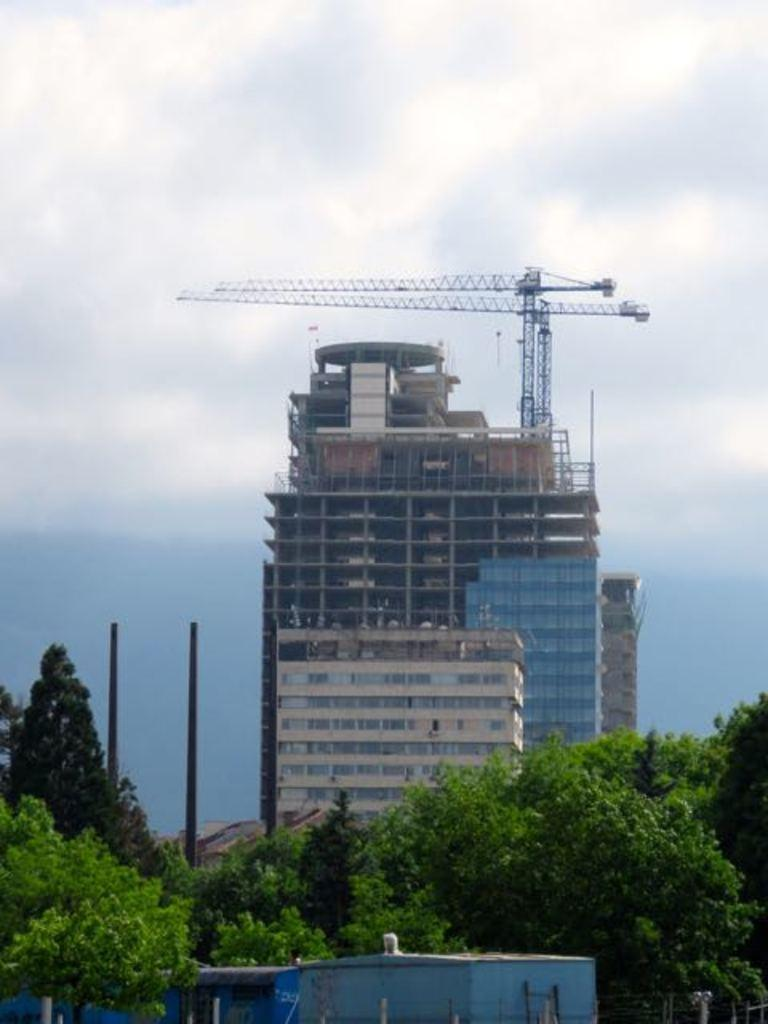What type of vegetation can be seen at the bottom of the image? There are trees at the bottom of the image. What type of structures are also present at the bottom of the image? There are sheds at the bottom of the image. What can be seen in the background of the image? There are buildings and the sky visible in the background of the image. What is the condition of the sky in the image? Clouds are present in the background of the image. What type of pain is being experienced by the person in the image? There is no person present in the image, so it is not possible to determine if anyone is experiencing pain. What record is being played in the image? There is no record player or music playing in the image. 